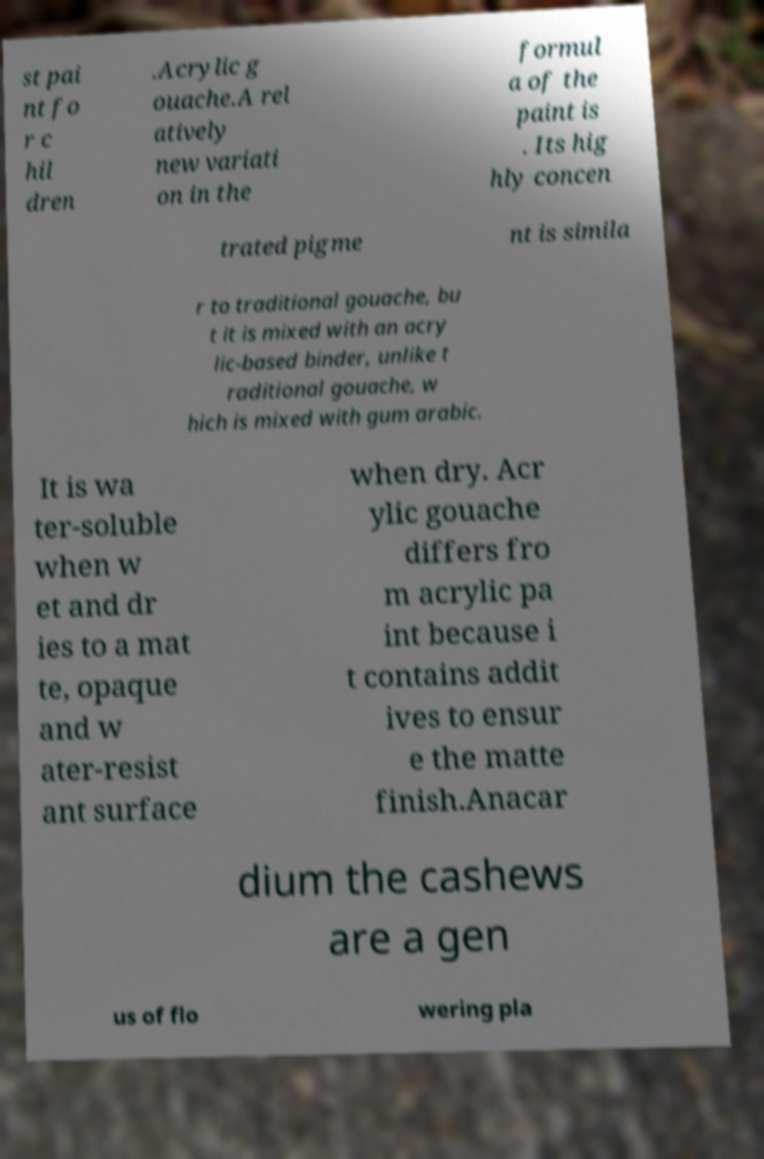Can you read and provide the text displayed in the image?This photo seems to have some interesting text. Can you extract and type it out for me? st pai nt fo r c hil dren .Acrylic g ouache.A rel atively new variati on in the formul a of the paint is . Its hig hly concen trated pigme nt is simila r to traditional gouache, bu t it is mixed with an acry lic-based binder, unlike t raditional gouache, w hich is mixed with gum arabic. It is wa ter-soluble when w et and dr ies to a mat te, opaque and w ater-resist ant surface when dry. Acr ylic gouache differs fro m acrylic pa int because i t contains addit ives to ensur e the matte finish.Anacar dium the cashews are a gen us of flo wering pla 